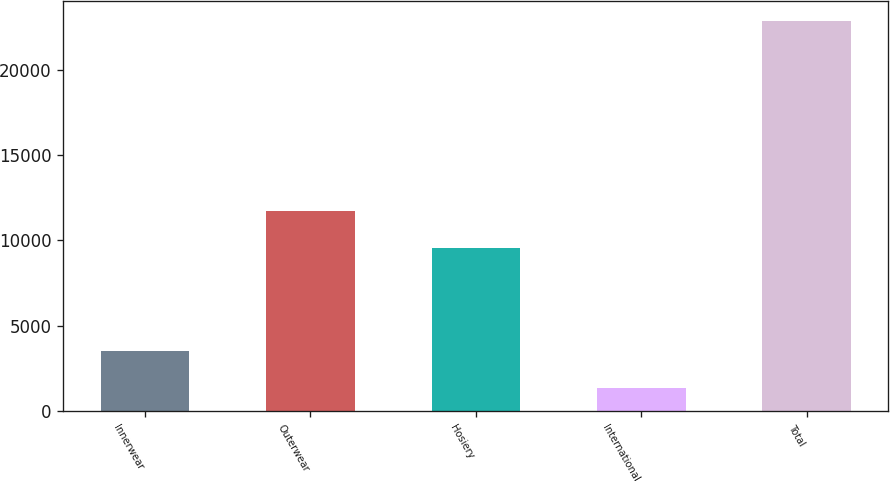Convert chart. <chart><loc_0><loc_0><loc_500><loc_500><bar_chart><fcel>Innerwear<fcel>Outerwear<fcel>Hosiery<fcel>International<fcel>Total<nl><fcel>3506.4<fcel>11726.4<fcel>9575<fcel>1355<fcel>22869<nl></chart> 